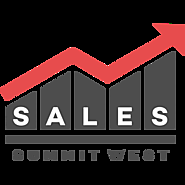Don't forget these rules:
 
1. **Be Direct and Concise**: Provide straightforward descriptions without adding interpretative or speculative elements.
2. **Use Segmented Details**: Break down details about different elements of an image into distinct sentences, focusing on one aspect at a time.
3. **Maintain a Descriptive Focus**: Prioritize purely visible elements of the image, avoiding conclusions or inferences.
4. **Follow a Logical Structure**: Begin with the central figure or subject and expand outward, detailing its appearance before addressing the surrounding setting.
5. **Avoid Juxtaposition**: Do not use comparison or contrast language; keep the description purely factual.
6. **Incorporate Specificity**: Mention age, gender, race, and specific brands or notable features when present, and clearly identify the medium if it's discernible. 
 
When writing descriptions, prioritize clarity and direct observation over embellishment or interpretation.
 
Write a detailed description of this image, do not forget about the texts on it if they exist. Also, do not forget to mention the type / style of the image. No bullet points. The image is a graphic logo design featuring the word "SALES" in bold, uppercase letters. Above the word "SALES," there is a stylized graph with four vertical bars increasing in height from left to right. The bars are black, and the last bar is connected to a red upward-pointing arrow, signifying growth or increase. Below the graph, the word "SUMMIT" is written in smaller uppercase letters, and even further below, the word "WEST" is in the same style but slightly larger than "SUMMIT." The background of the logo is white, which creates a stark contrast with the black and red elements. The logo conveys themes of sales performance, growth, and possibly indicates an event or organization related to these concepts in a western location or direction. 